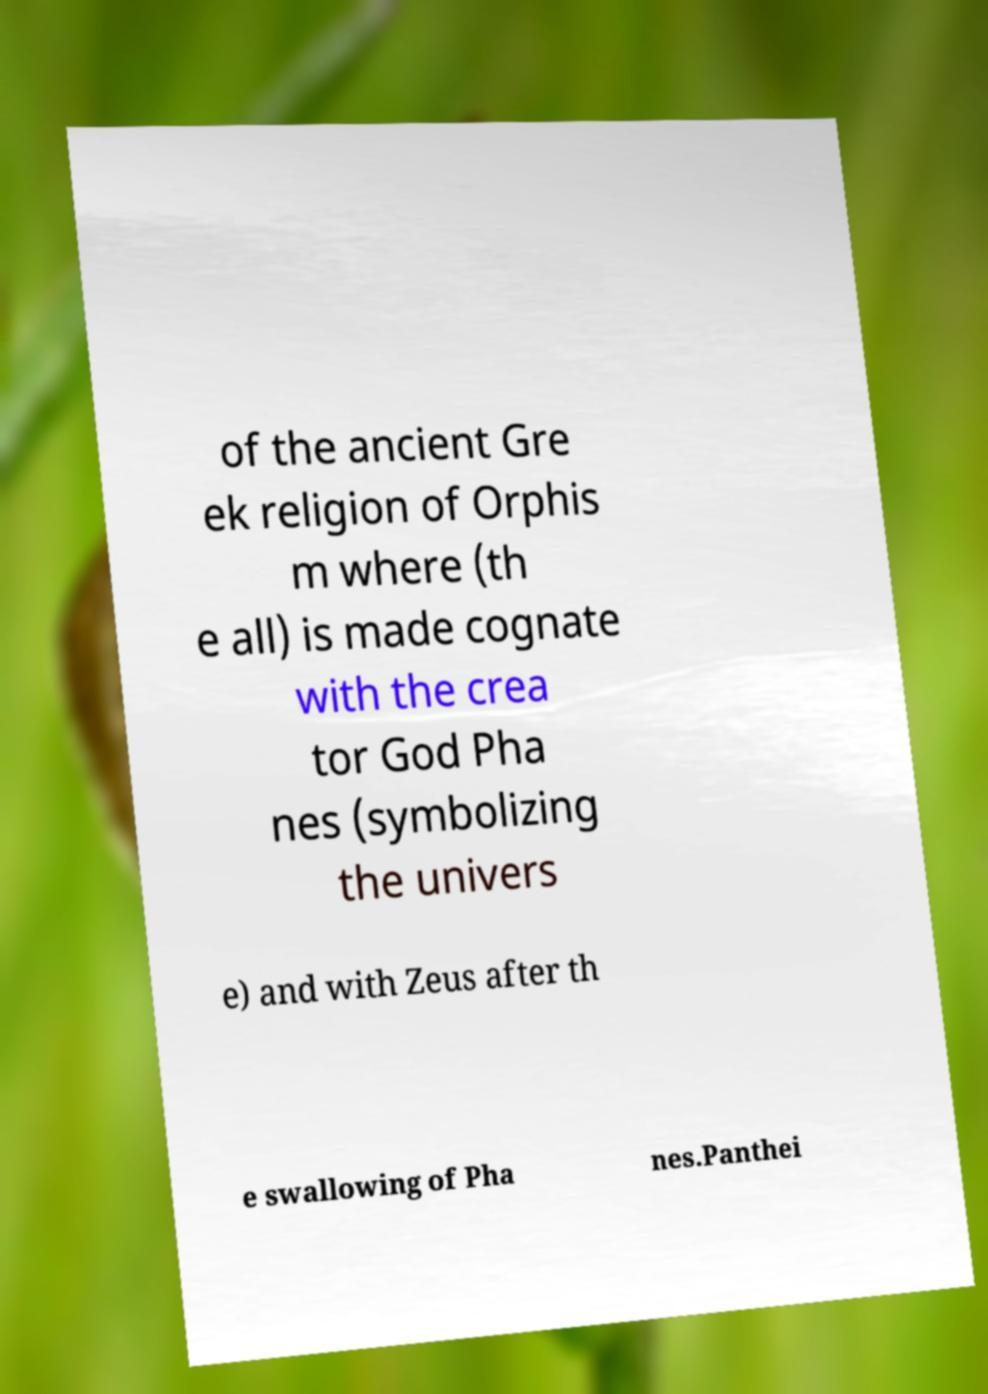Please identify and transcribe the text found in this image. of the ancient Gre ek religion of Orphis m where (th e all) is made cognate with the crea tor God Pha nes (symbolizing the univers e) and with Zeus after th e swallowing of Pha nes.Panthei 